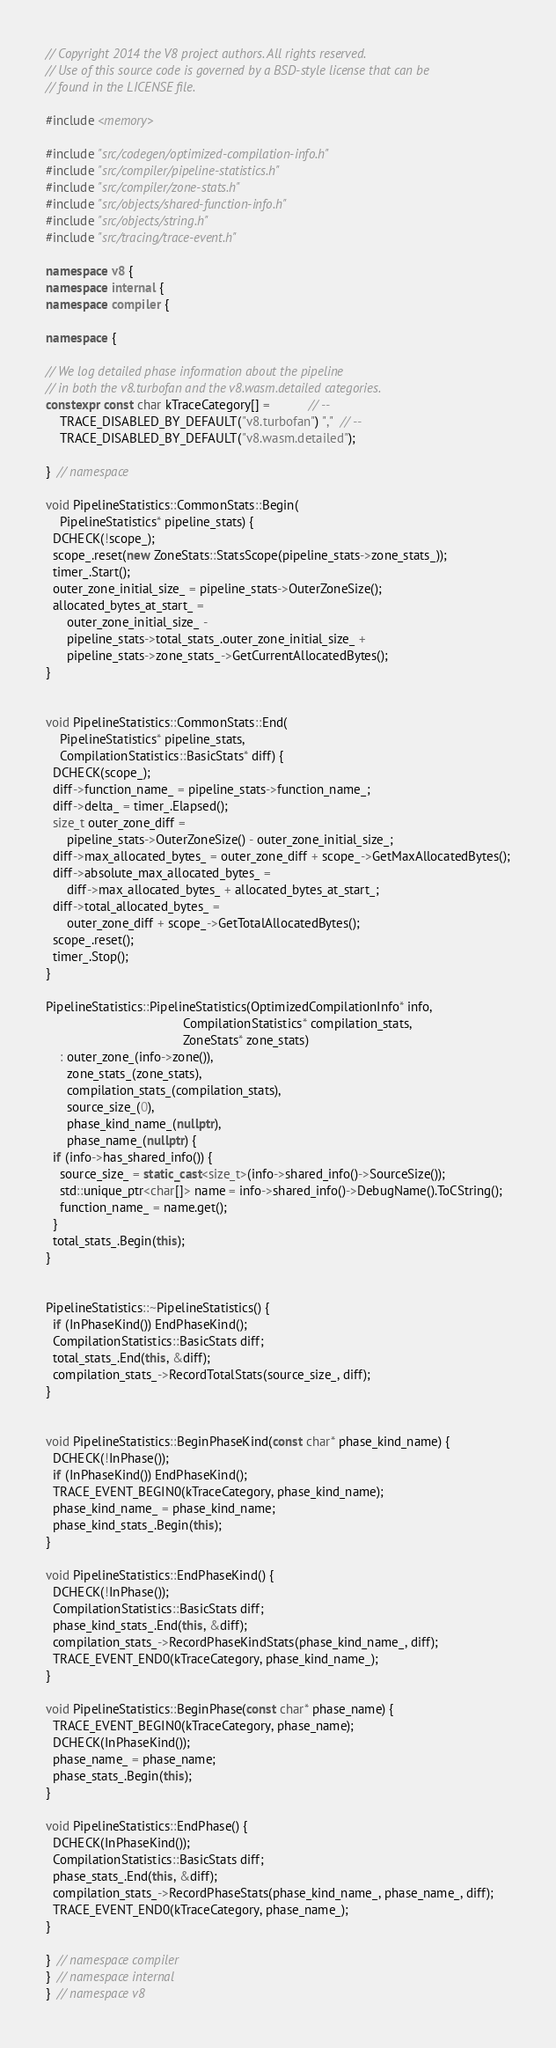<code> <loc_0><loc_0><loc_500><loc_500><_C++_>// Copyright 2014 the V8 project authors. All rights reserved.
// Use of this source code is governed by a BSD-style license that can be
// found in the LICENSE file.

#include <memory>

#include "src/codegen/optimized-compilation-info.h"
#include "src/compiler/pipeline-statistics.h"
#include "src/compiler/zone-stats.h"
#include "src/objects/shared-function-info.h"
#include "src/objects/string.h"
#include "src/tracing/trace-event.h"

namespace v8 {
namespace internal {
namespace compiler {

namespace {

// We log detailed phase information about the pipeline
// in both the v8.turbofan and the v8.wasm.detailed categories.
constexpr const char kTraceCategory[] =           // --
    TRACE_DISABLED_BY_DEFAULT("v8.turbofan") ","  // --
    TRACE_DISABLED_BY_DEFAULT("v8.wasm.detailed");

}  // namespace

void PipelineStatistics::CommonStats::Begin(
    PipelineStatistics* pipeline_stats) {
  DCHECK(!scope_);
  scope_.reset(new ZoneStats::StatsScope(pipeline_stats->zone_stats_));
  timer_.Start();
  outer_zone_initial_size_ = pipeline_stats->OuterZoneSize();
  allocated_bytes_at_start_ =
      outer_zone_initial_size_ -
      pipeline_stats->total_stats_.outer_zone_initial_size_ +
      pipeline_stats->zone_stats_->GetCurrentAllocatedBytes();
}


void PipelineStatistics::CommonStats::End(
    PipelineStatistics* pipeline_stats,
    CompilationStatistics::BasicStats* diff) {
  DCHECK(scope_);
  diff->function_name_ = pipeline_stats->function_name_;
  diff->delta_ = timer_.Elapsed();
  size_t outer_zone_diff =
      pipeline_stats->OuterZoneSize() - outer_zone_initial_size_;
  diff->max_allocated_bytes_ = outer_zone_diff + scope_->GetMaxAllocatedBytes();
  diff->absolute_max_allocated_bytes_ =
      diff->max_allocated_bytes_ + allocated_bytes_at_start_;
  diff->total_allocated_bytes_ =
      outer_zone_diff + scope_->GetTotalAllocatedBytes();
  scope_.reset();
  timer_.Stop();
}

PipelineStatistics::PipelineStatistics(OptimizedCompilationInfo* info,
                                       CompilationStatistics* compilation_stats,
                                       ZoneStats* zone_stats)
    : outer_zone_(info->zone()),
      zone_stats_(zone_stats),
      compilation_stats_(compilation_stats),
      source_size_(0),
      phase_kind_name_(nullptr),
      phase_name_(nullptr) {
  if (info->has_shared_info()) {
    source_size_ = static_cast<size_t>(info->shared_info()->SourceSize());
    std::unique_ptr<char[]> name = info->shared_info()->DebugName().ToCString();
    function_name_ = name.get();
  }
  total_stats_.Begin(this);
}


PipelineStatistics::~PipelineStatistics() {
  if (InPhaseKind()) EndPhaseKind();
  CompilationStatistics::BasicStats diff;
  total_stats_.End(this, &diff);
  compilation_stats_->RecordTotalStats(source_size_, diff);
}


void PipelineStatistics::BeginPhaseKind(const char* phase_kind_name) {
  DCHECK(!InPhase());
  if (InPhaseKind()) EndPhaseKind();
  TRACE_EVENT_BEGIN0(kTraceCategory, phase_kind_name);
  phase_kind_name_ = phase_kind_name;
  phase_kind_stats_.Begin(this);
}

void PipelineStatistics::EndPhaseKind() {
  DCHECK(!InPhase());
  CompilationStatistics::BasicStats diff;
  phase_kind_stats_.End(this, &diff);
  compilation_stats_->RecordPhaseKindStats(phase_kind_name_, diff);
  TRACE_EVENT_END0(kTraceCategory, phase_kind_name_);
}

void PipelineStatistics::BeginPhase(const char* phase_name) {
  TRACE_EVENT_BEGIN0(kTraceCategory, phase_name);
  DCHECK(InPhaseKind());
  phase_name_ = phase_name;
  phase_stats_.Begin(this);
}

void PipelineStatistics::EndPhase() {
  DCHECK(InPhaseKind());
  CompilationStatistics::BasicStats diff;
  phase_stats_.End(this, &diff);
  compilation_stats_->RecordPhaseStats(phase_kind_name_, phase_name_, diff);
  TRACE_EVENT_END0(kTraceCategory, phase_name_);
}

}  // namespace compiler
}  // namespace internal
}  // namespace v8
</code> 